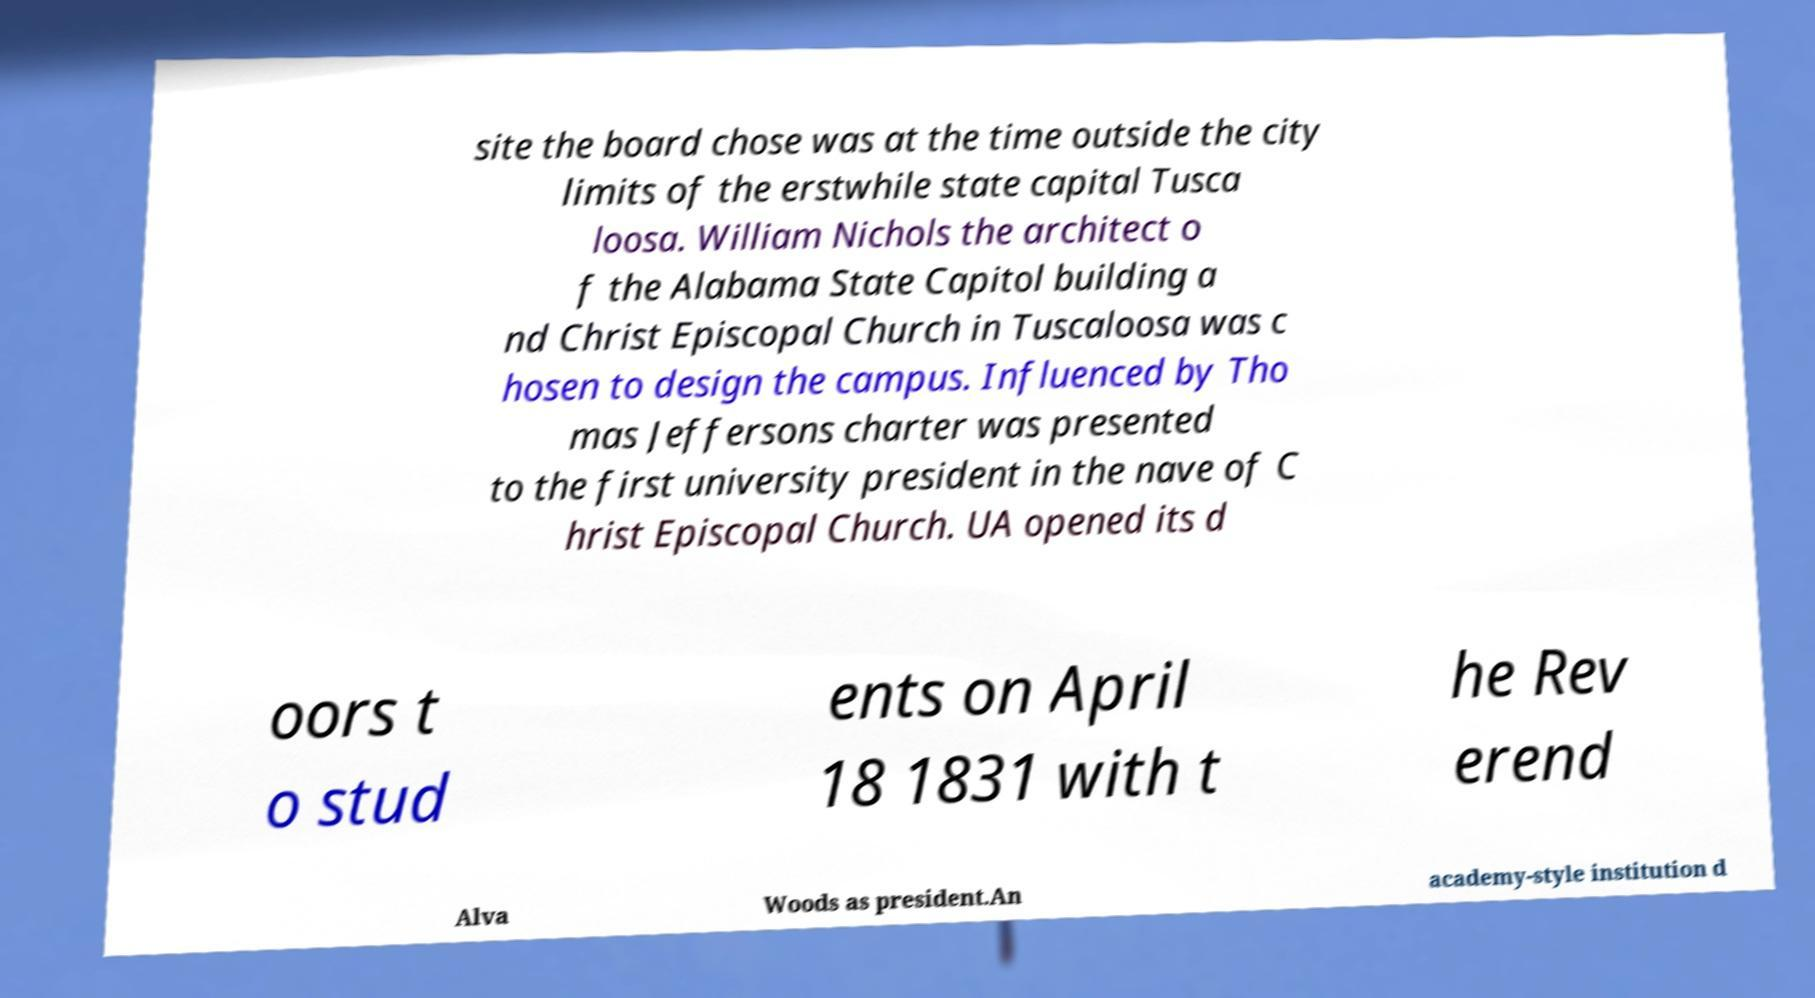I need the written content from this picture converted into text. Can you do that? site the board chose was at the time outside the city limits of the erstwhile state capital Tusca loosa. William Nichols the architect o f the Alabama State Capitol building a nd Christ Episcopal Church in Tuscaloosa was c hosen to design the campus. Influenced by Tho mas Jeffersons charter was presented to the first university president in the nave of C hrist Episcopal Church. UA opened its d oors t o stud ents on April 18 1831 with t he Rev erend Alva Woods as president.An academy-style institution d 